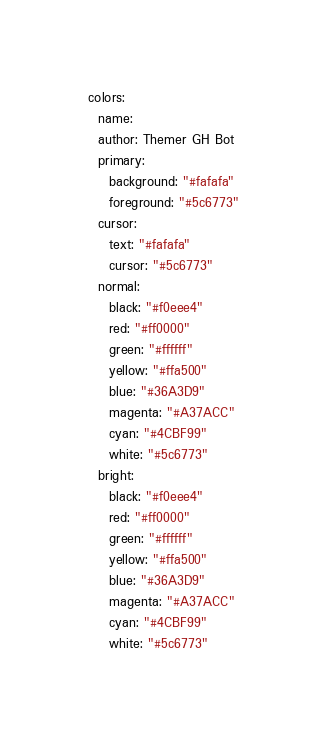<code> <loc_0><loc_0><loc_500><loc_500><_YAML_>colors:
  name:   
  author: Themer GH Bot
  primary:
    background: "#fafafa"
    foreground: "#5c6773"
  cursor:
    text: "#fafafa"
    cursor: "#5c6773"
  normal:
    black: "#f0eee4"
    red: "#ff0000"
    green: "#ffffff"
    yellow: "#ffa500"
    blue: "#36A3D9"
    magenta: "#A37ACC"
    cyan: "#4CBF99"
    white: "#5c6773"
  bright:
    black: "#f0eee4"
    red: "#ff0000"
    green: "#ffffff"
    yellow: "#ffa500"
    blue: "#36A3D9"
    magenta: "#A37ACC"
    cyan: "#4CBF99"
    white: "#5c6773"
</code> 